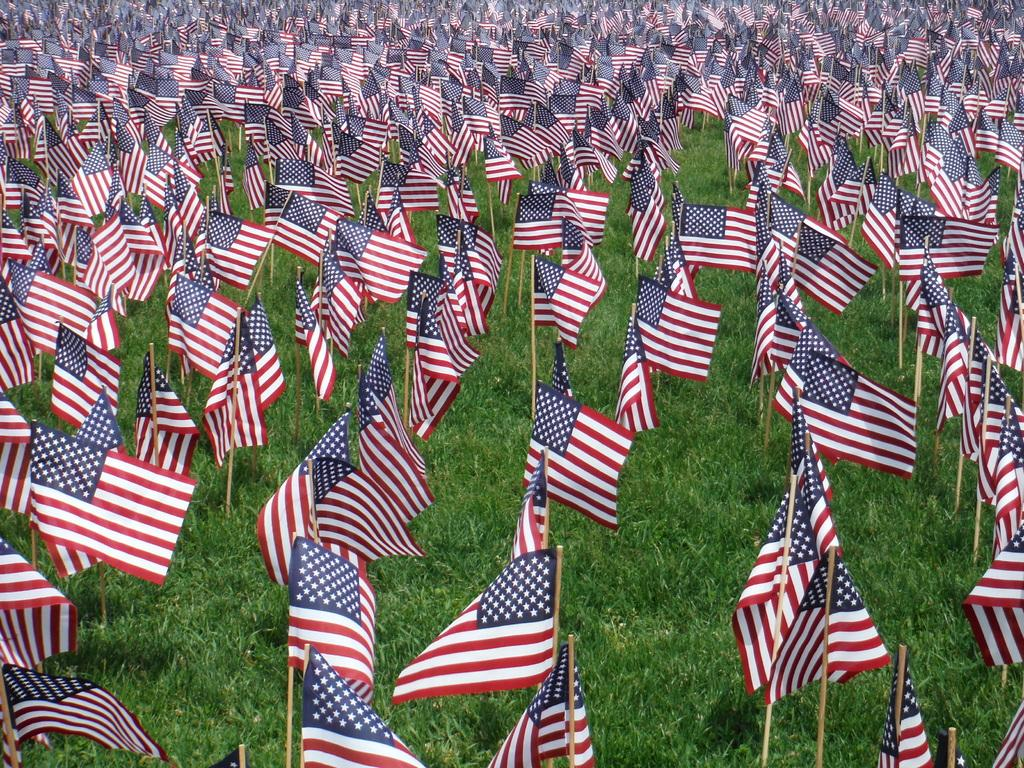What is the main subject of the image? The main subject of the image is many flags. Where are the flags located in the image? The flags are in the grass. What type of muscle can be seen flexing in the image? There is no muscle present in the image; it features many flags in the grass. What kind of meat is being cooked on the grill in the image? There is no grill or meat present in the image; it only shows flags in the grass. 